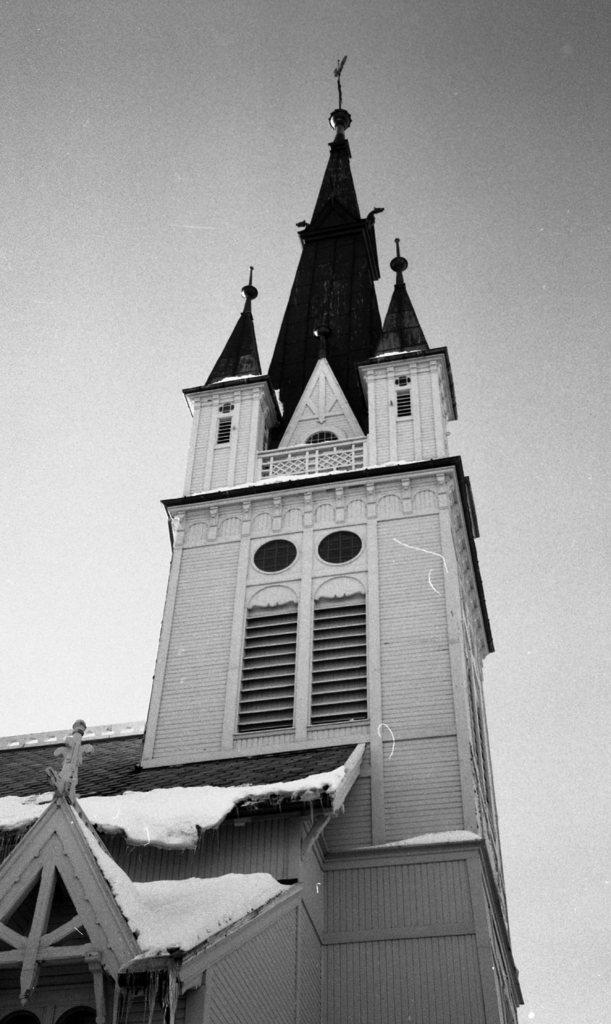What type of structure is present in the image? There is a building in the image. What is covering the roof of the building? There is snow on the roof of the building. What can be seen at the top of the image? The sky is visible at the top of the image. What is the color scheme of the image? The image is black and white. What question is being asked by the team in the image? There is no team present in the image, and no question is being asked. 